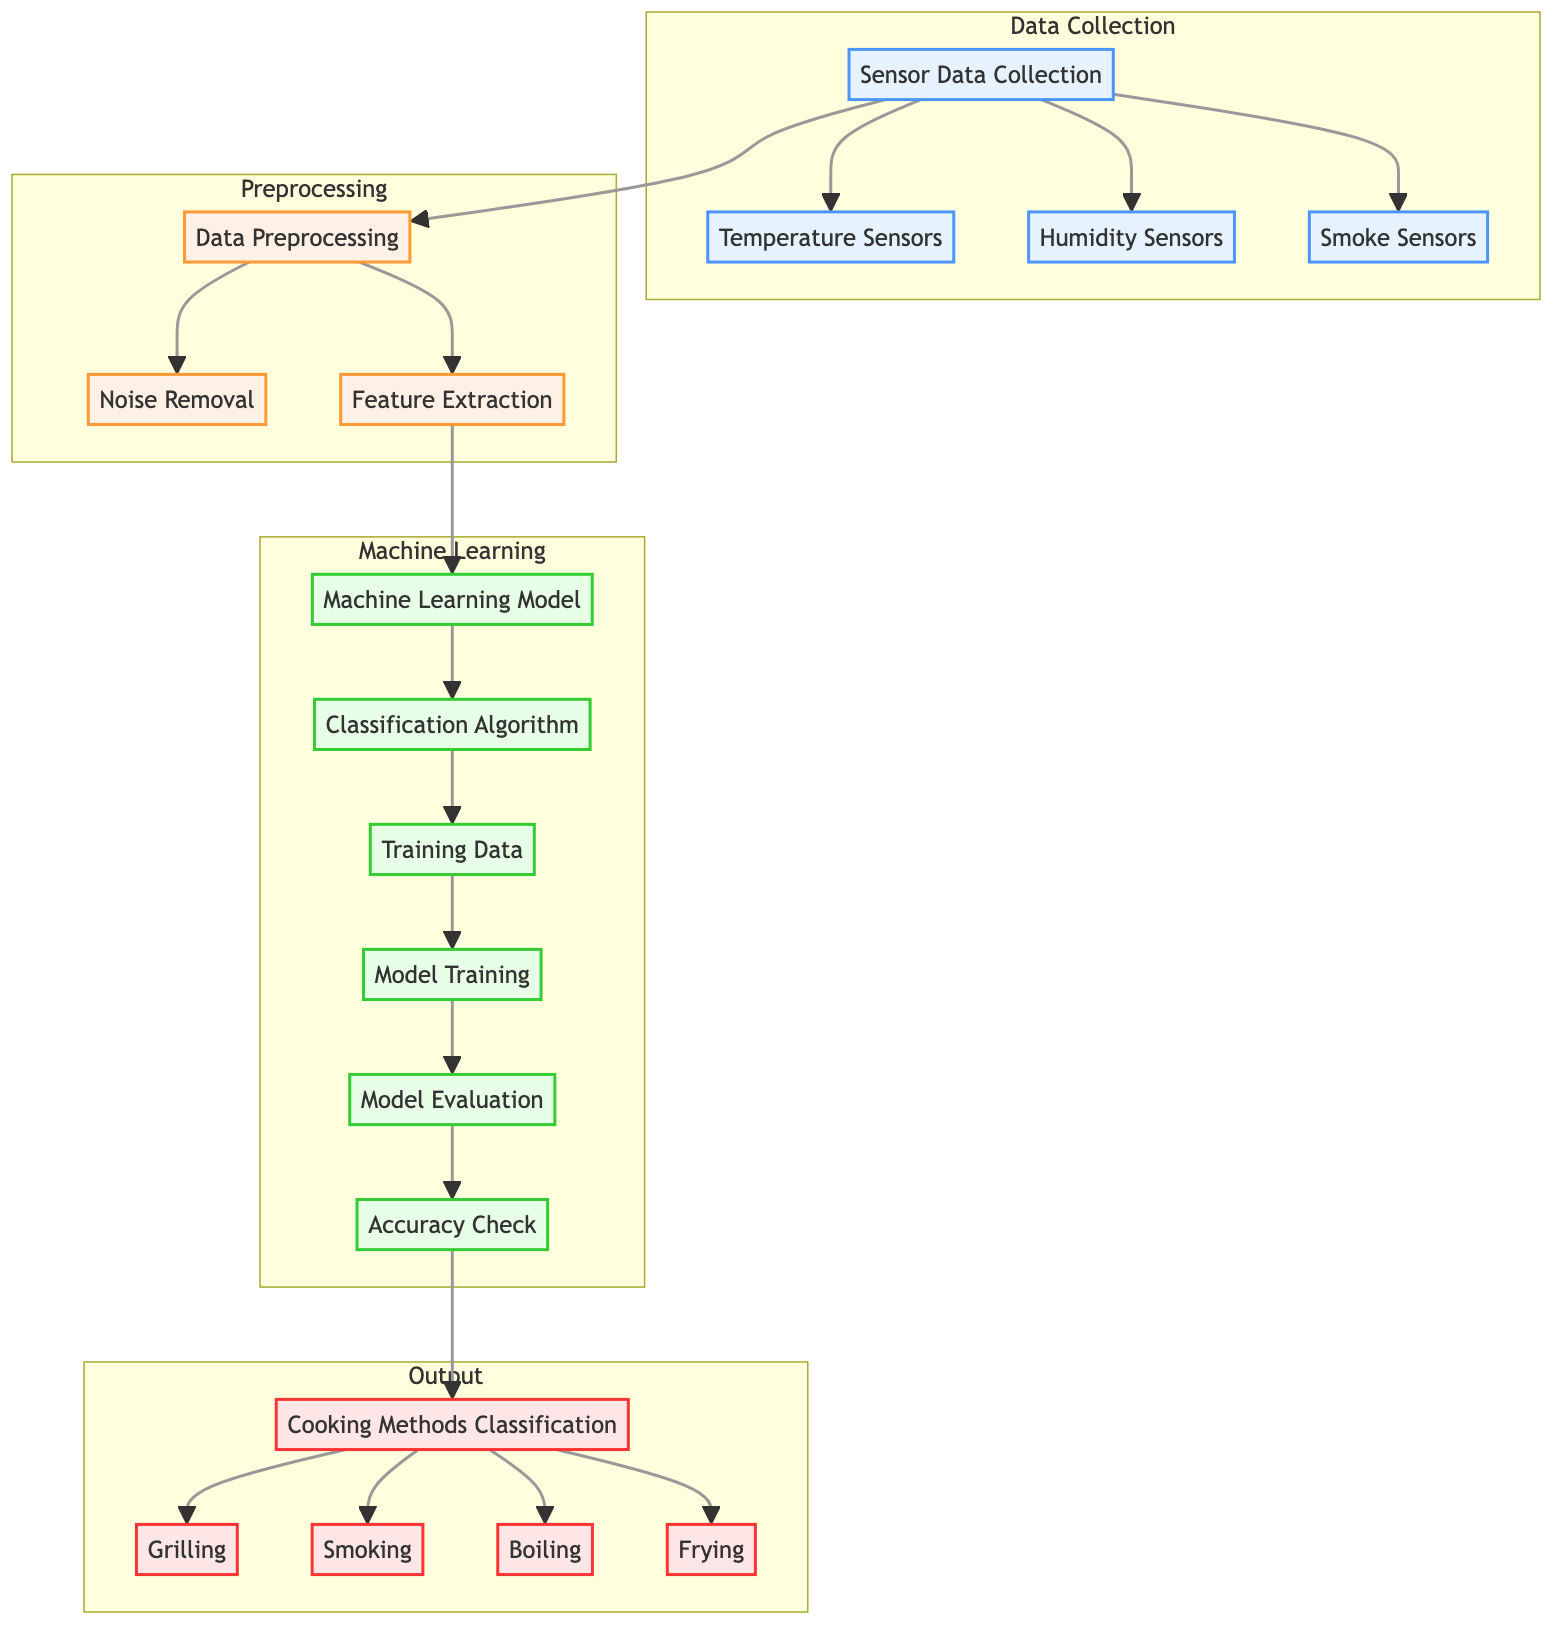What are the three types of sensors used in data collection? The diagram outlines three sensor types connected to the data collection node: Temperature Sensors, Humidity Sensors, and Smoke Sensors. These are the distinct types of sensors shown in the 'Data Collection' section of the diagram.
Answer: Temperature Sensors, Humidity Sensors, Smoke Sensors How many nodes are in the "Machine Learning" subgraph? The "Machine Learning" subgraph consists of six distinct nodes: Machine Learning Model, Classification Algorithm, Training Data, Model Training, Model Evaluation, and Accuracy Check. By counting each node in this subgraph, we confirm the number.
Answer: 6 What is the last step before "Cooking Methods Classification"? The last step preceding "Cooking Methods Classification" is the Accuracy Check, where the model's effectiveness is evaluated to ensure accurate classification of cooking methods. This is identified in the output flow leading to classification.
Answer: Accuracy Check Which components are part of the "Preprocessing" subgraph? The preprocessing subgraph contains three components: Data Preprocessing, Noise Removal, and Feature Extraction connected hierarchically. These components work together to prepare the data for further processing in the machine learning model.
Answer: Data Preprocessing, Noise Removal, Feature Extraction What nodes lead into the "Model Training"? The nodes that lead into "Model Training" are Training Data and the Classification Algorithm. Training Data provides the necessary information, and the Classification Algorithm outlines the method used for training, all of which is crucial for the model development process.
Answer: Training Data, Classification Algorithm How is "Temperature Sensors" connected to "Data Preprocessing"? "Temperature Sensors" is connected to "Data Preprocessing" through the main Data Collection node. Once sensor data is collected, it flows directly into preprocessing, signifying its pivotal role in data preparation.
Answer: Directly connects through Data Collection What is the outcome of "Model Evaluation"? The outcome of "Model Evaluation" is the Accuracy Check, which assesses how well the model has been trained and its classification accuracy regarding traditional cooking methods. This progression ensures the model's performance aligns with the expected outcomes.
Answer: Accuracy Check What is the role of "Feature Extraction"? The role of Feature Extraction is to identify and select the relevant features from the preprocessed data, which are essential for training the machine learning model effectively. This step ensures only useful information informs subsequent model building.
Answer: Selecting relevant features What type of diagram is this? This is a Machine Learning Diagram representing the steps involved in classifying traditional cooking methods using data collected from sensors. The diagram illustrates the entire workflow from data collection to output classification.
Answer: Machine Learning Diagram 